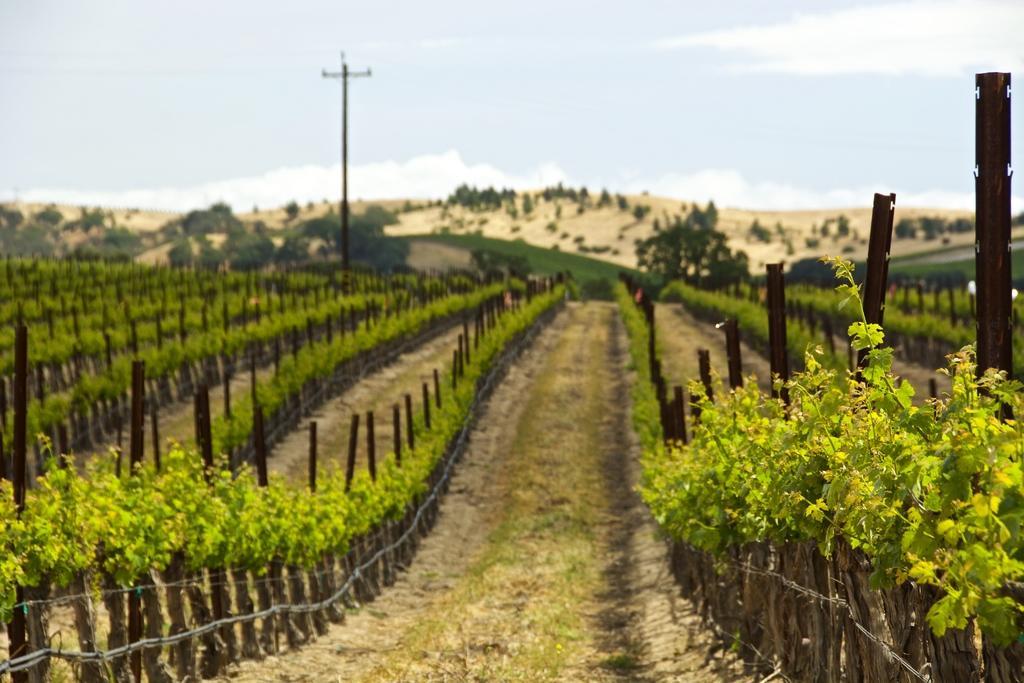What type of vegetation can be seen in the image? There is a group of plants and a group of trees in the image. What type of barrier is present in the image? There is a wooden fence in the image. What type of ground surface is visible in the image? Grass is present in the image, and there is also a pathway. What structure is visible in the image? A utility pole is visible in the image. What is visible in the sky in the image? The sky is visible in the image, and it appears to be cloudy. What is the price of the alarm clock in the image? There is no alarm clock present in the image. How does the group of plants laugh in the image? Plants do not have the ability to laugh, so this question is not applicable to the image. 